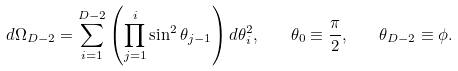Convert formula to latex. <formula><loc_0><loc_0><loc_500><loc_500>d \Omega _ { D - 2 } = \sum ^ { D - 2 } _ { i = 1 } \left ( \prod _ { j = 1 } ^ { i } \sin ^ { 2 } \theta _ { j - 1 } \right ) d \theta _ { i } ^ { 2 } , \quad \theta _ { 0 } \equiv \frac { \pi } { 2 } , \quad \theta _ { D - 2 } \equiv \phi .</formula> 